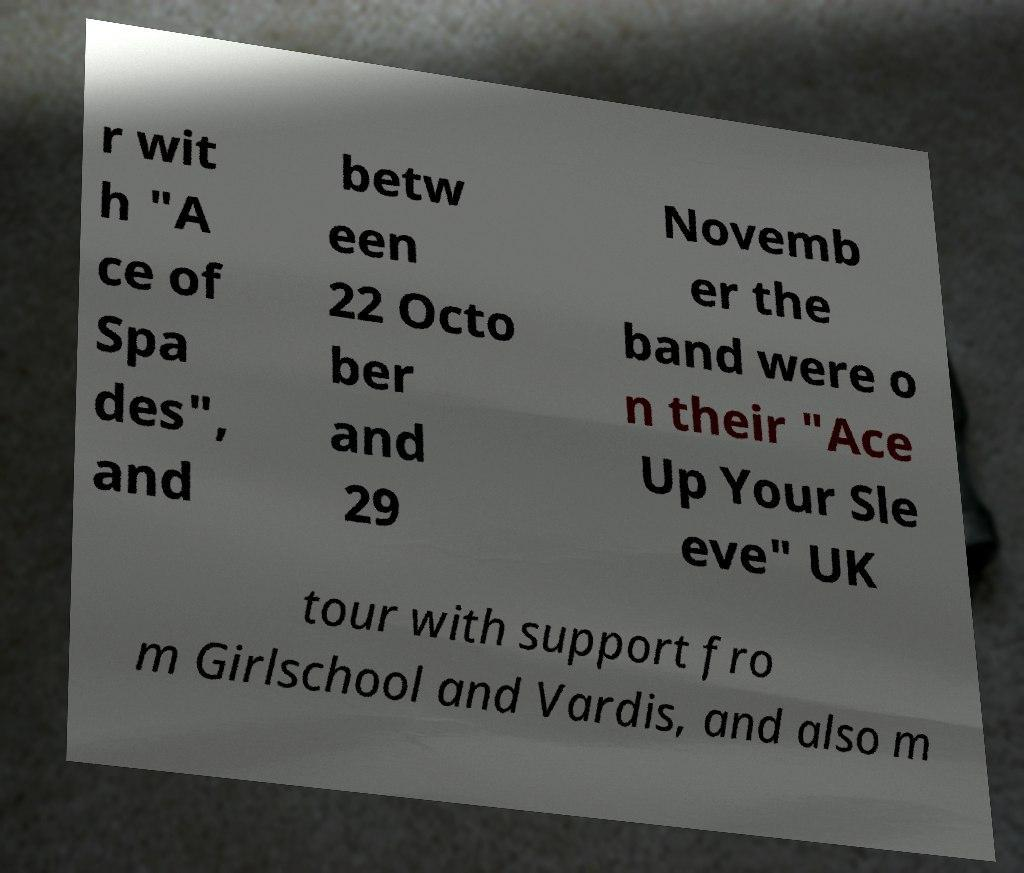There's text embedded in this image that I need extracted. Can you transcribe it verbatim? r wit h "A ce of Spa des", and betw een 22 Octo ber and 29 Novemb er the band were o n their "Ace Up Your Sle eve" UK tour with support fro m Girlschool and Vardis, and also m 